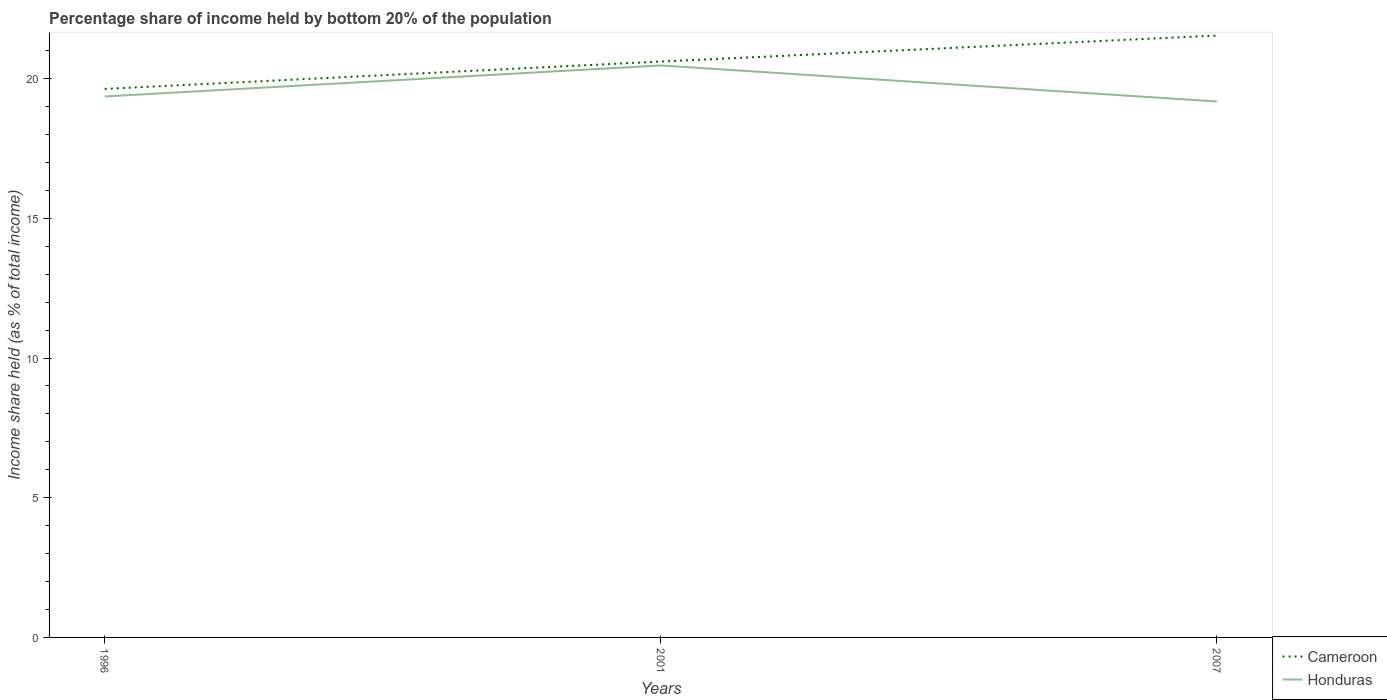How many different coloured lines are there?
Your answer should be compact. 2. Does the line corresponding to Cameroon intersect with the line corresponding to Honduras?
Offer a terse response. No. Across all years, what is the maximum share of income held by bottom 20% of the population in Honduras?
Your answer should be very brief. 19.18. What is the total share of income held by bottom 20% of the population in Honduras in the graph?
Ensure brevity in your answer.  -1.11. What is the difference between the highest and the second highest share of income held by bottom 20% of the population in Cameroon?
Provide a succinct answer. 1.91. Are the values on the major ticks of Y-axis written in scientific E-notation?
Your response must be concise. No. Does the graph contain grids?
Your answer should be compact. No. How many legend labels are there?
Make the answer very short. 2. How are the legend labels stacked?
Ensure brevity in your answer.  Vertical. What is the title of the graph?
Offer a terse response. Percentage share of income held by bottom 20% of the population. What is the label or title of the X-axis?
Make the answer very short. Years. What is the label or title of the Y-axis?
Your response must be concise. Income share held (as % of total income). What is the Income share held (as % of total income) in Cameroon in 1996?
Give a very brief answer. 19.63. What is the Income share held (as % of total income) of Honduras in 1996?
Provide a succinct answer. 19.36. What is the Income share held (as % of total income) in Cameroon in 2001?
Your answer should be very brief. 20.61. What is the Income share held (as % of total income) in Honduras in 2001?
Offer a terse response. 20.47. What is the Income share held (as % of total income) in Cameroon in 2007?
Give a very brief answer. 21.54. What is the Income share held (as % of total income) in Honduras in 2007?
Your answer should be compact. 19.18. Across all years, what is the maximum Income share held (as % of total income) in Cameroon?
Give a very brief answer. 21.54. Across all years, what is the maximum Income share held (as % of total income) of Honduras?
Offer a very short reply. 20.47. Across all years, what is the minimum Income share held (as % of total income) in Cameroon?
Provide a short and direct response. 19.63. Across all years, what is the minimum Income share held (as % of total income) in Honduras?
Make the answer very short. 19.18. What is the total Income share held (as % of total income) of Cameroon in the graph?
Keep it short and to the point. 61.78. What is the total Income share held (as % of total income) of Honduras in the graph?
Offer a very short reply. 59.01. What is the difference between the Income share held (as % of total income) in Cameroon in 1996 and that in 2001?
Give a very brief answer. -0.98. What is the difference between the Income share held (as % of total income) of Honduras in 1996 and that in 2001?
Give a very brief answer. -1.11. What is the difference between the Income share held (as % of total income) in Cameroon in 1996 and that in 2007?
Ensure brevity in your answer.  -1.91. What is the difference between the Income share held (as % of total income) of Honduras in 1996 and that in 2007?
Ensure brevity in your answer.  0.18. What is the difference between the Income share held (as % of total income) of Cameroon in 2001 and that in 2007?
Give a very brief answer. -0.93. What is the difference between the Income share held (as % of total income) in Honduras in 2001 and that in 2007?
Ensure brevity in your answer.  1.29. What is the difference between the Income share held (as % of total income) in Cameroon in 1996 and the Income share held (as % of total income) in Honduras in 2001?
Provide a succinct answer. -0.84. What is the difference between the Income share held (as % of total income) in Cameroon in 1996 and the Income share held (as % of total income) in Honduras in 2007?
Make the answer very short. 0.45. What is the difference between the Income share held (as % of total income) of Cameroon in 2001 and the Income share held (as % of total income) of Honduras in 2007?
Provide a succinct answer. 1.43. What is the average Income share held (as % of total income) of Cameroon per year?
Your answer should be very brief. 20.59. What is the average Income share held (as % of total income) in Honduras per year?
Provide a succinct answer. 19.67. In the year 1996, what is the difference between the Income share held (as % of total income) of Cameroon and Income share held (as % of total income) of Honduras?
Provide a succinct answer. 0.27. In the year 2001, what is the difference between the Income share held (as % of total income) of Cameroon and Income share held (as % of total income) of Honduras?
Provide a short and direct response. 0.14. In the year 2007, what is the difference between the Income share held (as % of total income) in Cameroon and Income share held (as % of total income) in Honduras?
Provide a succinct answer. 2.36. What is the ratio of the Income share held (as % of total income) in Cameroon in 1996 to that in 2001?
Provide a short and direct response. 0.95. What is the ratio of the Income share held (as % of total income) of Honduras in 1996 to that in 2001?
Ensure brevity in your answer.  0.95. What is the ratio of the Income share held (as % of total income) in Cameroon in 1996 to that in 2007?
Ensure brevity in your answer.  0.91. What is the ratio of the Income share held (as % of total income) of Honduras in 1996 to that in 2007?
Provide a succinct answer. 1.01. What is the ratio of the Income share held (as % of total income) in Cameroon in 2001 to that in 2007?
Keep it short and to the point. 0.96. What is the ratio of the Income share held (as % of total income) of Honduras in 2001 to that in 2007?
Your answer should be compact. 1.07. What is the difference between the highest and the second highest Income share held (as % of total income) in Honduras?
Offer a very short reply. 1.11. What is the difference between the highest and the lowest Income share held (as % of total income) of Cameroon?
Give a very brief answer. 1.91. What is the difference between the highest and the lowest Income share held (as % of total income) in Honduras?
Make the answer very short. 1.29. 